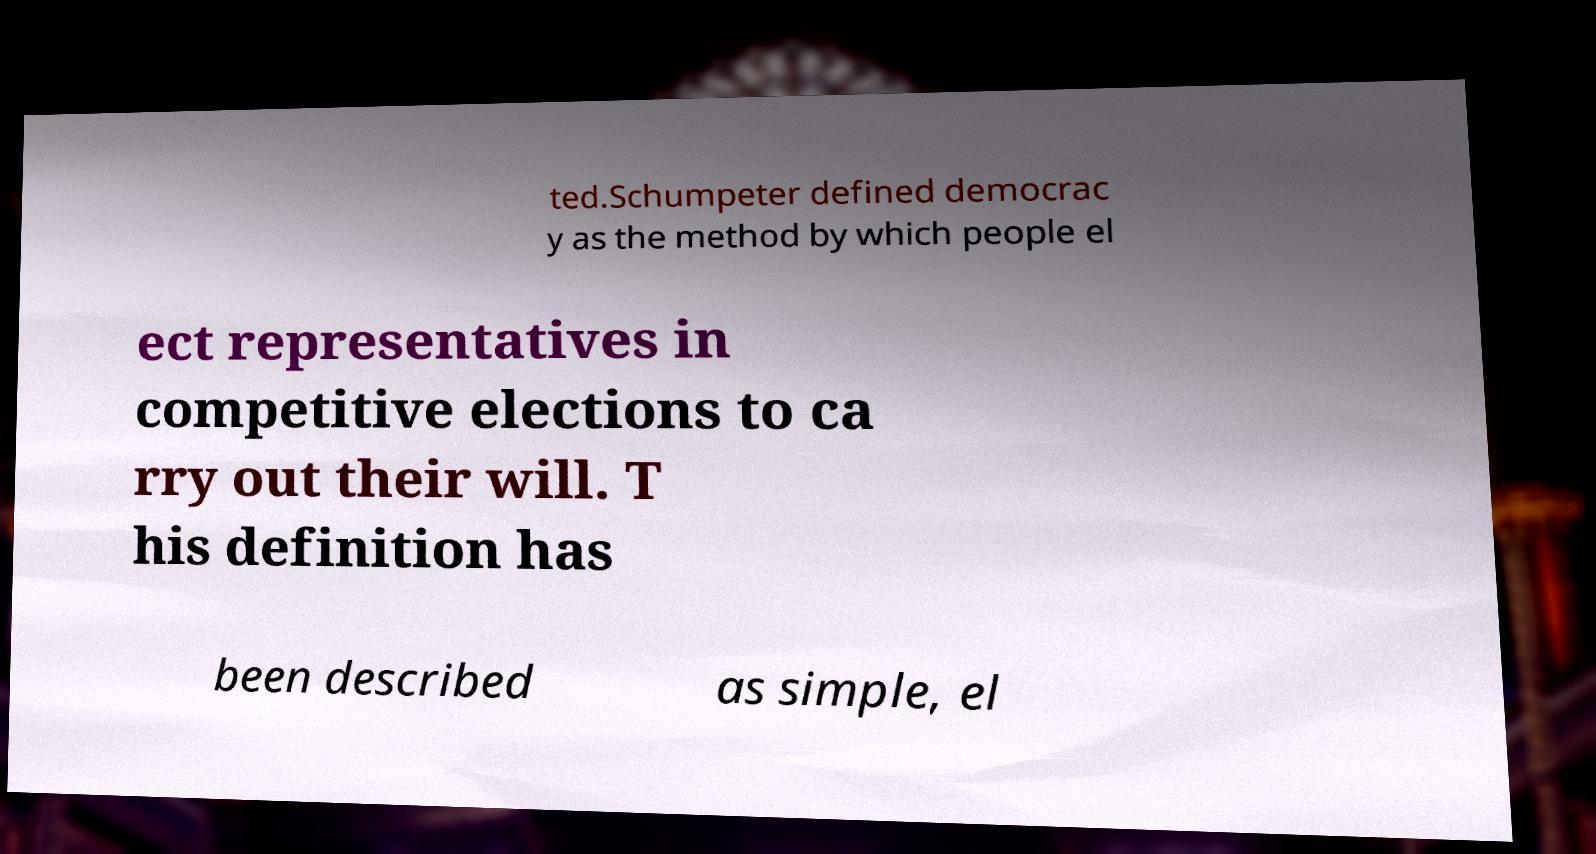Can you accurately transcribe the text from the provided image for me? ted.Schumpeter defined democrac y as the method by which people el ect representatives in competitive elections to ca rry out their will. T his definition has been described as simple, el 